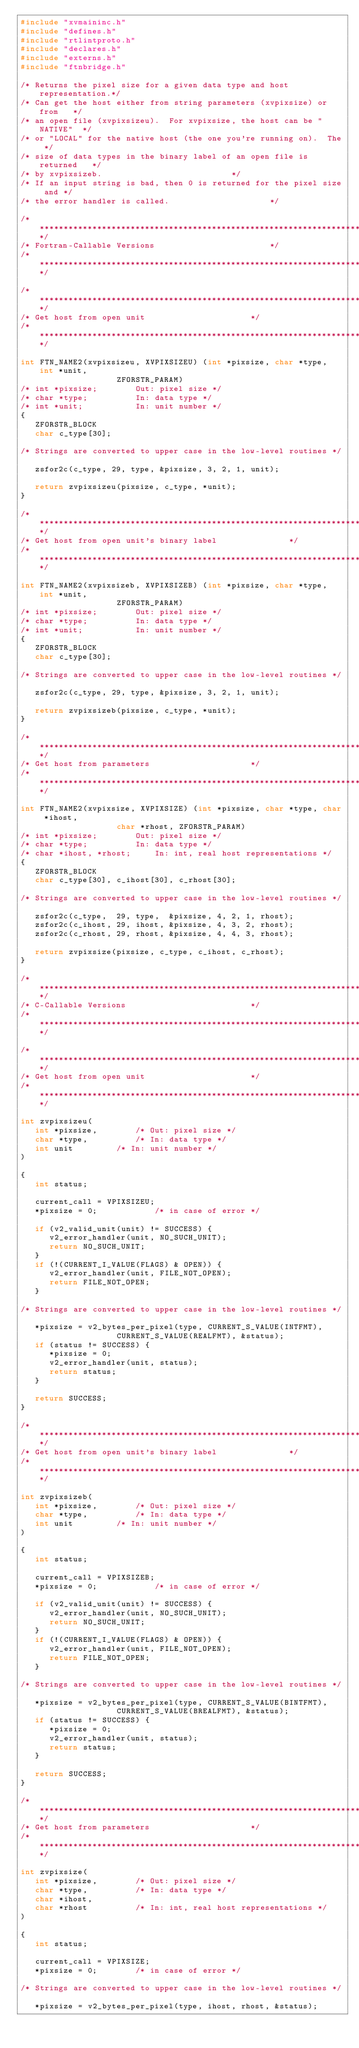<code> <loc_0><loc_0><loc_500><loc_500><_C_>#include "xvmaininc.h"
#include "defines.h"
#include "rtlintproto.h"
#include "declares.h"
#include "externs.h"
#include "ftnbridge.h"

/* Returns the pixel size for a given data type and host representation.*/
/* Can get the host either from string parameters (xvpixsize) or from	*/
/* an open file (xvpixsizeu).  For xvpixsize, the host can be "NATIVE"	*/
/* or "LOCAL" for the native host (the one you're running on).  The	*/
/* size of data types in the binary label of an open file is returned	*/
/* by xvpixsizeb.							*/
/* If an input string is bad, then 0 is returned for the pixel size and	*/
/* the error handler is called.						*/

/************************************************************************/
/* Fortran-Callable Versions						*/
/************************************************************************/

/************************************************************************/
/* Get host from open unit						*/
/************************************************************************/

int FTN_NAME2(xvpixsizeu, XVPIXSIZEU) (int *pixsize, char *type, int *unit,
					ZFORSTR_PARAM)
/* int *pixsize;		Out: pixel size */
/* char *type;			In: data type */
/* int *unit;			In: unit number */
{
   ZFORSTR_BLOCK
   char c_type[30];

/* Strings are converted to upper case in the low-level routines */

   zsfor2c(c_type, 29, type, &pixsize, 3, 2, 1, unit);

   return zvpixsizeu(pixsize, c_type, *unit);
}

/************************************************************************/
/* Get host from open unit's binary label				*/
/************************************************************************/

int FTN_NAME2(xvpixsizeb, XVPIXSIZEB) (int *pixsize, char *type, int *unit,
					ZFORSTR_PARAM)
/* int *pixsize;		Out: pixel size */
/* char *type;			In: data type */
/* int *unit;			In: unit number */
{
   ZFORSTR_BLOCK
   char c_type[30];

/* Strings are converted to upper case in the low-level routines */

   zsfor2c(c_type, 29, type, &pixsize, 3, 2, 1, unit);

   return zvpixsizeb(pixsize, c_type, *unit);
}

/************************************************************************/
/* Get host from parameters						*/
/************************************************************************/

int FTN_NAME2(xvpixsize, XVPIXSIZE) (int *pixsize, char *type, char *ihost,
					char *rhost, ZFORSTR_PARAM)
/* int *pixsize;		Out: pixel size */
/* char *type;			In: data type */
/* char *ihost, *rhost;		In: int, real host representations */
{
   ZFORSTR_BLOCK
   char c_type[30], c_ihost[30], c_rhost[30];

/* Strings are converted to upper case in the low-level routines */

   zsfor2c(c_type,  29, type,  &pixsize, 4, 2, 1, rhost);
   zsfor2c(c_ihost, 29, ihost, &pixsize, 4, 3, 2, rhost);
   zsfor2c(c_rhost, 29, rhost, &pixsize, 4, 4, 3, rhost);

   return zvpixsize(pixsize, c_type, c_ihost, c_rhost);
}

/************************************************************************/
/* C-Callable Versions							*/
/************************************************************************/

/************************************************************************/
/* Get host from open unit						*/
/************************************************************************/

int zvpixsizeu(
   int *pixsize,		/* Out: pixel size */
   char *type,			/* In: data type */
   int unit			/* In: unit number */
)

{
   int status;

   current_call = VPIXSIZEU;
   *pixsize = 0;			/* in case of error */

   if (v2_valid_unit(unit) != SUCCESS) {
      v2_error_handler(unit, NO_SUCH_UNIT);
      return NO_SUCH_UNIT;
   }
   if (!(CURRENT_I_VALUE(FLAGS) & OPEN)) {
      v2_error_handler(unit, FILE_NOT_OPEN);
      return FILE_NOT_OPEN;
   }

/* Strings are converted to upper case in the low-level routines */

   *pixsize = v2_bytes_per_pixel(type, CURRENT_S_VALUE(INTFMT),
				    CURRENT_S_VALUE(REALFMT), &status);
   if (status != SUCCESS) {
      *pixsize = 0;
      v2_error_handler(unit, status);
      return status;
   }

   return SUCCESS;
}

/************************************************************************/
/* Get host from open unit's binary label				*/
/************************************************************************/

int zvpixsizeb(
   int *pixsize,		/* Out: pixel size */
   char *type,			/* In: data type */
   int unit			/* In: unit number */
)

{
   int status;

   current_call = VPIXSIZEB;
   *pixsize = 0;			/* in case of error */

   if (v2_valid_unit(unit) != SUCCESS) {
      v2_error_handler(unit, NO_SUCH_UNIT);
      return NO_SUCH_UNIT;
   }
   if (!(CURRENT_I_VALUE(FLAGS) & OPEN)) {
      v2_error_handler(unit, FILE_NOT_OPEN);
      return FILE_NOT_OPEN;
   }

/* Strings are converted to upper case in the low-level routines */

   *pixsize = v2_bytes_per_pixel(type, CURRENT_S_VALUE(BINTFMT),
				    CURRENT_S_VALUE(BREALFMT), &status);
   if (status != SUCCESS) {
      *pixsize = 0;
      v2_error_handler(unit, status);
      return status;
   }

   return SUCCESS;
}

/************************************************************************/
/* Get host from parameters						*/
/************************************************************************/

int zvpixsize(
   int *pixsize,		/* Out: pixel size */
   char *type,			/* In: data type */
   char *ihost,
   char *rhost			/* In: int, real host representations */
)

{
   int status;

   current_call = VPIXSIZE;
   *pixsize = 0;		/* in case of error */

/* Strings are converted to upper case in the low-level routines */

   *pixsize = v2_bytes_per_pixel(type, ihost, rhost, &status);
</code> 